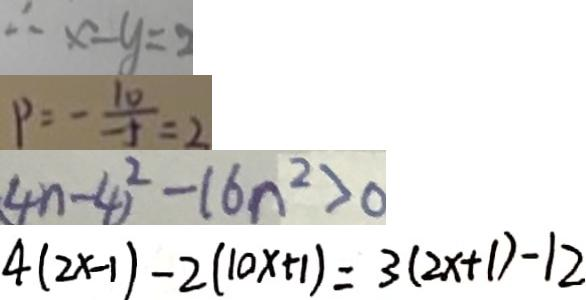Convert formula to latex. <formula><loc_0><loc_0><loc_500><loc_500>\therefore x - y = 2 
 P = - \frac { 1 0 } { - 5 } = 2 
 ( 4 n - 4 ) ^ { 2 } - 1 6 n ^ { 2 } > 0 
 4 ( 2 x - 1 ) - 2 ( 1 0 x + 1 ) = 3 ( 2 x + 1 ) - 1 2</formula> 